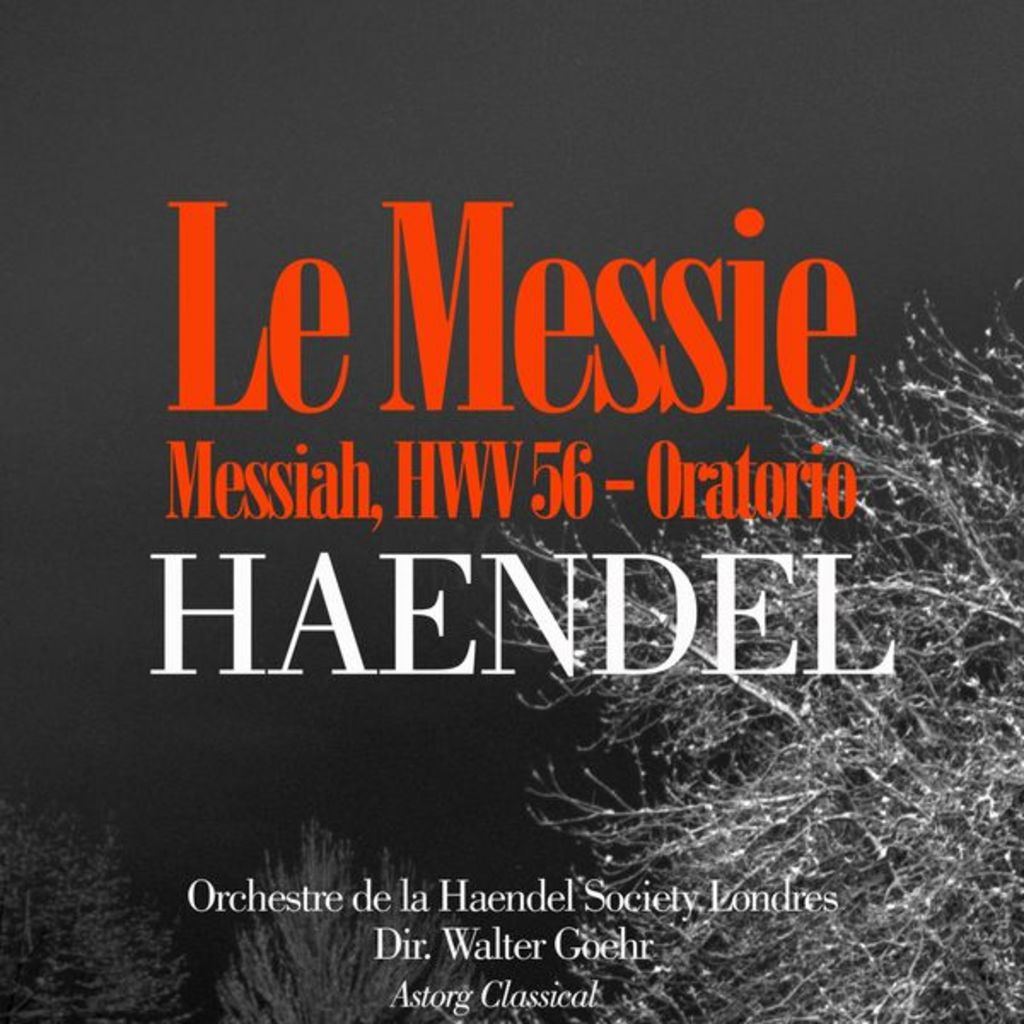What is the significance of the music piece 'Messiah, HWV 56' by Handel? 'Messiah, HWV 56' is one of George Frideric Handel's most famous works, celebrated particularly for its powerful choral sections and the Hallelujah chorus. Composed in 1741, it is a baroque-era oratorio that narrates Jesus Christ's nativity, passion, resurrection, and ascension. 